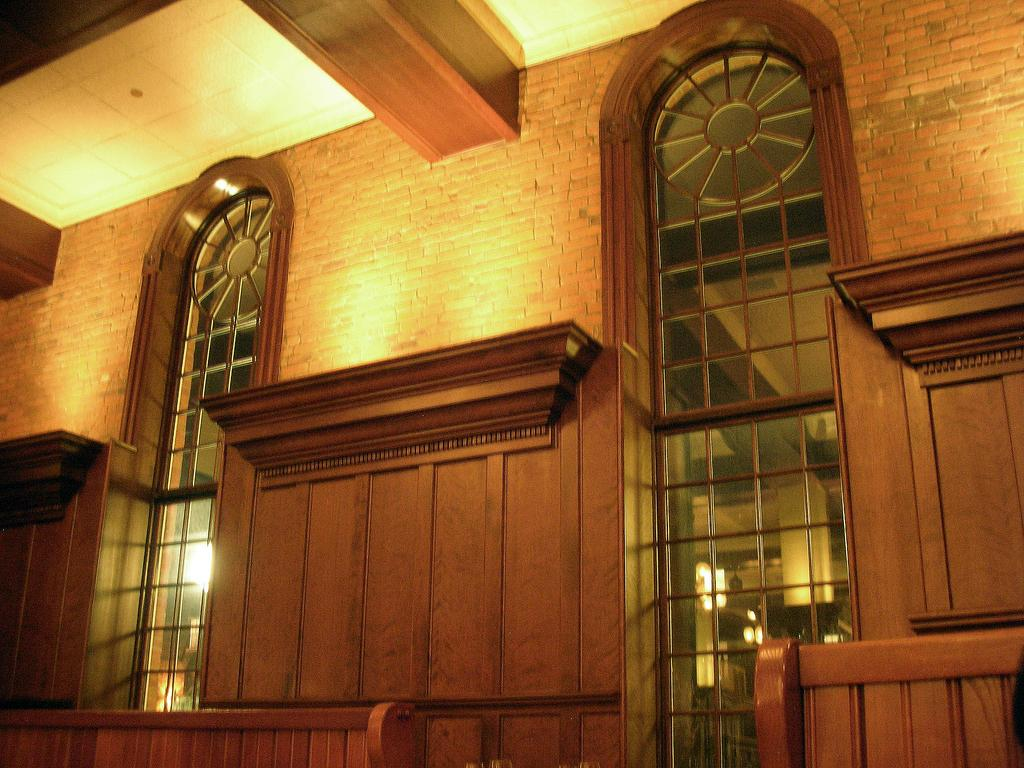What is located in front in the image? There is a wall in front in the image. How many windows can be seen in the image? There are 2 windows visible in the image. What part of the room is visible at the top of the image? The ceiling is visible at the top of the image. What type of wool is draped over the arm of the chair in the image? There is no chair or wool present in the image; it only features a wall and windows. 